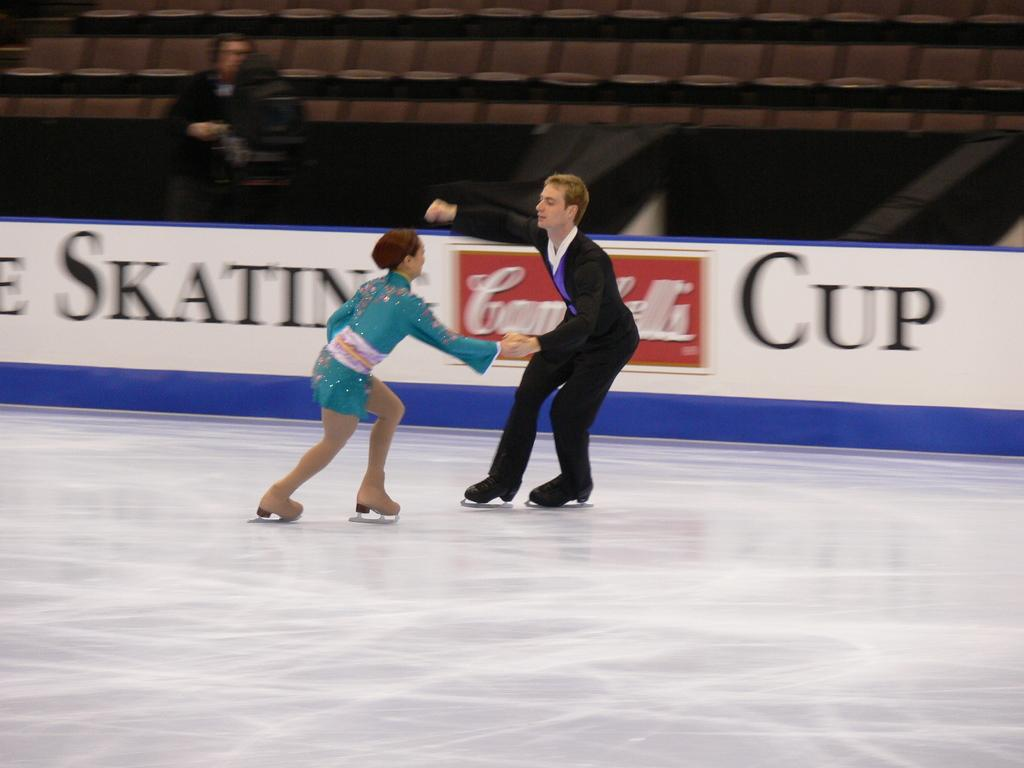Who is present in the image? There is a girl and a boy in the image. What are the girl and the boy doing in the image? They are both skating in the image. Where are they skating? They are skating in an ice skating stadium. What can be seen in the background of the image? There are stadium seats visible in the background. What additional detail can be observed in the image? There is a white banner in the image. What type of string is being used to tie the girl's bun in the image? There is no girl with a bun in the image, and therefore no string is present. What type of corn is being served in the ice skating stadium in the image? There is no mention of corn or any food being served in the image. 